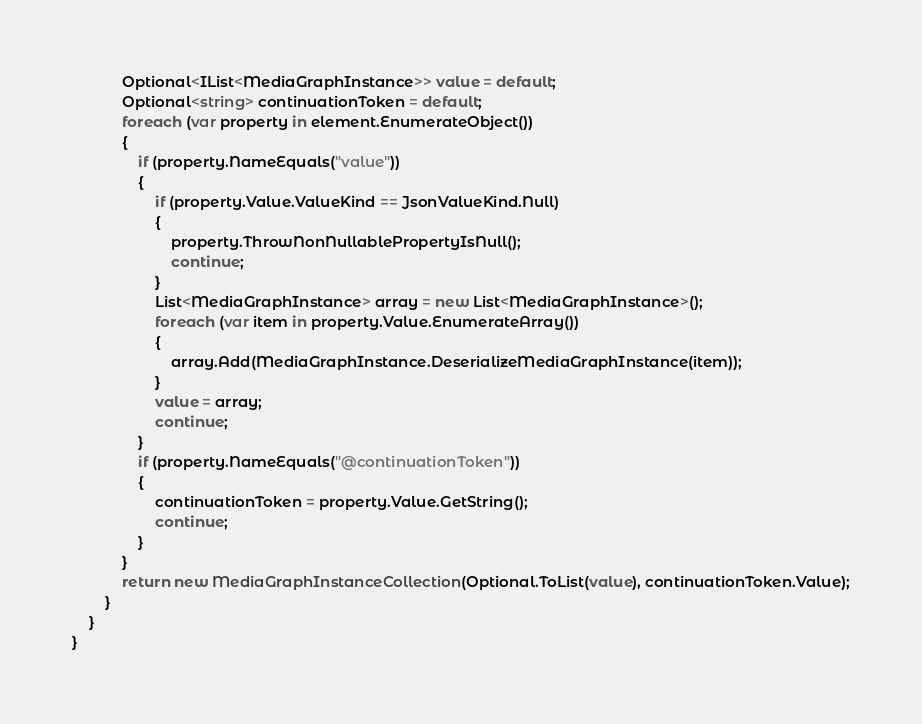<code> <loc_0><loc_0><loc_500><loc_500><_C#_>            Optional<IList<MediaGraphInstance>> value = default;
            Optional<string> continuationToken = default;
            foreach (var property in element.EnumerateObject())
            {
                if (property.NameEquals("value"))
                {
                    if (property.Value.ValueKind == JsonValueKind.Null)
                    {
                        property.ThrowNonNullablePropertyIsNull();
                        continue;
                    }
                    List<MediaGraphInstance> array = new List<MediaGraphInstance>();
                    foreach (var item in property.Value.EnumerateArray())
                    {
                        array.Add(MediaGraphInstance.DeserializeMediaGraphInstance(item));
                    }
                    value = array;
                    continue;
                }
                if (property.NameEquals("@continuationToken"))
                {
                    continuationToken = property.Value.GetString();
                    continue;
                }
            }
            return new MediaGraphInstanceCollection(Optional.ToList(value), continuationToken.Value);
        }
    }
}
</code> 